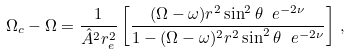<formula> <loc_0><loc_0><loc_500><loc_500>\Omega _ { c } - \Omega = \frac { 1 } { \hat { A } ^ { 2 } r _ { e } ^ { 2 } } \left [ \frac { ( \Omega - \omega ) r ^ { 2 } \sin ^ { 2 } \theta \ e ^ { - 2 \nu } } { 1 - ( \Omega - \omega ) ^ { 2 } r ^ { 2 } \sin ^ { 2 } \theta \ e ^ { - 2 \nu } } \right ] \, ,</formula> 